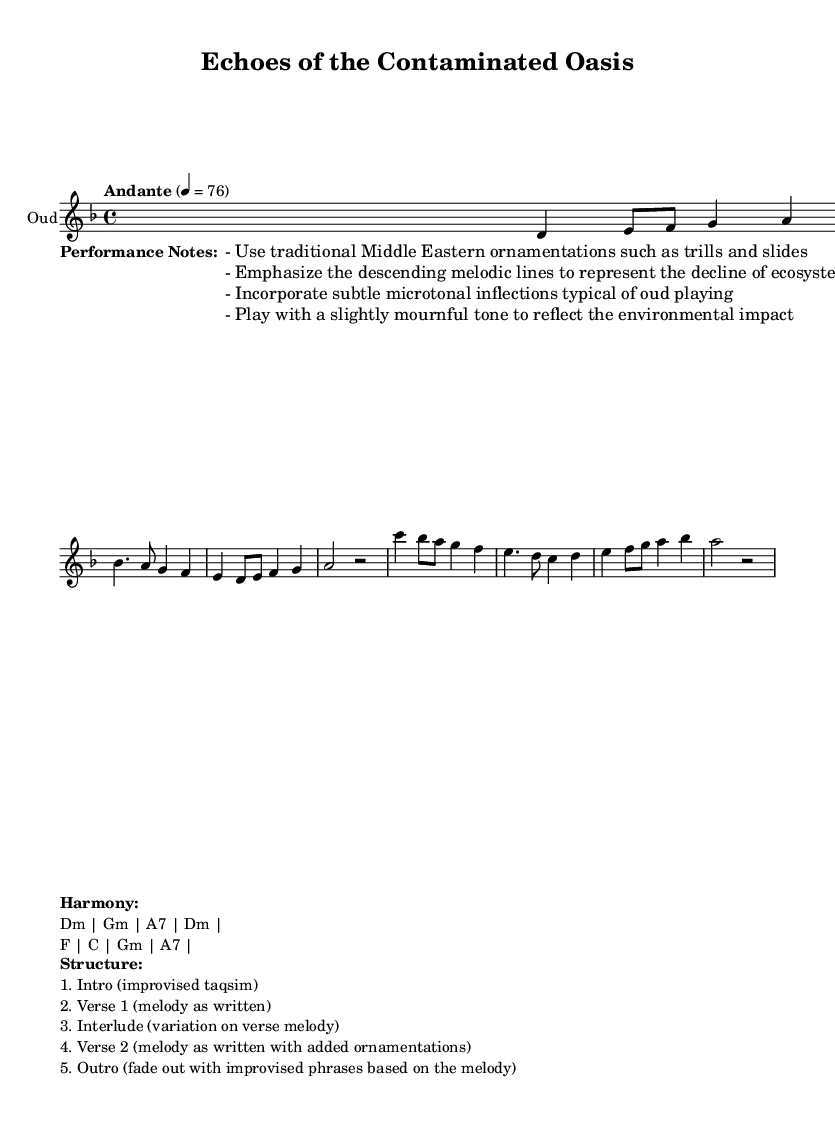What is the title of this piece? The title is indicated at the top of the sheet music, and directly states "Echoes of the Contaminated Oasis."
Answer: Echoes of the Contaminated Oasis What is the key signature of this music? The key signature is found in the music notation, which indicates D minor (one flat).
Answer: D minor What is the time signature of the piece? The time signature is noted at the beginning of the staff, which shows that the piece is in 4/4 time.
Answer: 4/4 What is the tempo marking for this piece? The tempo marking is provided below the title, stating "Andante" with a metronome marking of 76.
Answer: Andante, 76 How many sections are there in the structure of this piece? The structure indicates five distinct sections: Intro, Verse 1, Interlude, Verse 2, and Outro.
Answer: Five What is the harmony progression used in the piece? The harmony progression is explicitly indicated below the music with the chords: Dm, Gm, A7, Dm, F, C, Gm, A7.
Answer: Dm, Gm, A7, Dm, F, C, Gm, A7 What specific ornamentations are suggested for performance? The performance notes in the lyrics section detail suggested ornamentations such as trills and slides, as well as microtonal inflections.
Answer: Trills and slides 